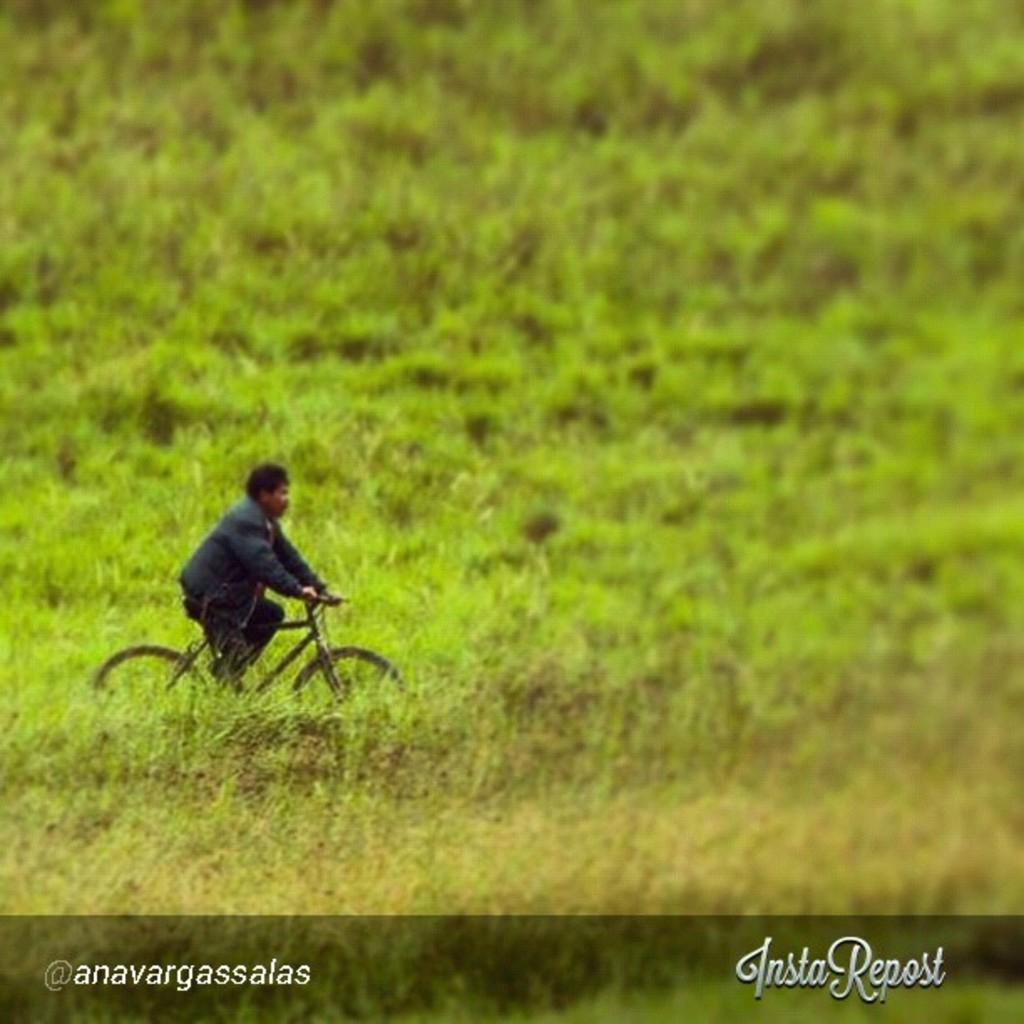What can be seen at the bottom of the image? There are watermarks at the bottom of the image. What is the person in the image doing? The person is riding a bicycle on the left side of the image. What type of vegetation is present in the image? There are plants in the middle of the image. What is the person teaching in the image? There is no indication in the image that the person is teaching anything. Can you see a cave in the image? There is no cave present in the image. 